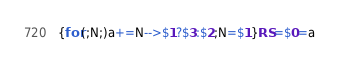<code> <loc_0><loc_0><loc_500><loc_500><_Awk_>{for(;N;)a+=N-->$1?$3:$2;N=$1}RS=$0=a</code> 